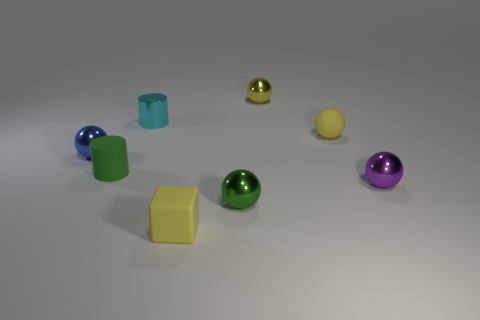Are there any tiny green matte objects that have the same shape as the tiny purple thing?
Make the answer very short. No. What number of things are yellow blocks or blue balls?
Make the answer very short. 2. What number of purple balls are on the right side of the small yellow matte thing that is right of the yellow matte thing that is left of the yellow matte sphere?
Offer a very short reply. 1. What is the material of the other tiny yellow object that is the same shape as the small yellow shiny thing?
Make the answer very short. Rubber. There is a thing that is right of the small yellow block and to the left of the tiny yellow metallic thing; what material is it?
Your answer should be compact. Metal. Are there fewer small purple objects that are left of the small yellow rubber ball than yellow objects in front of the tiny cube?
Your response must be concise. No. What number of other things are there of the same size as the rubber ball?
Keep it short and to the point. 7. What shape is the yellow matte thing that is in front of the small yellow matte object that is behind the tiny rubber object in front of the green metal thing?
Your response must be concise. Cube. How many purple things are either tiny metallic spheres or matte spheres?
Your answer should be compact. 1. There is a small purple thing to the right of the small cube; what number of blocks are on the right side of it?
Offer a terse response. 0. 